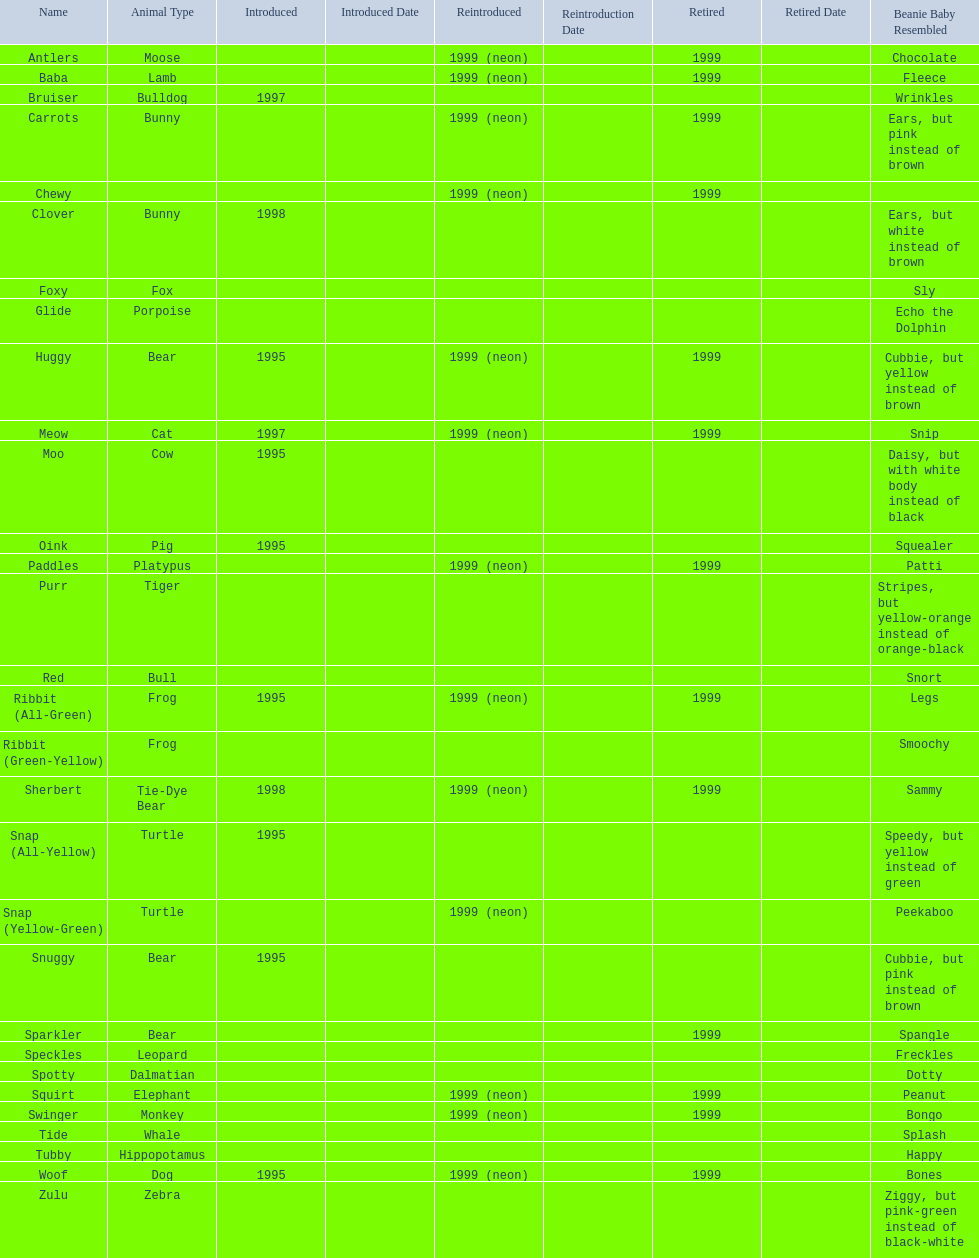What are all the different names of the pillow pals? Antlers, Baba, Bruiser, Carrots, Chewy, Clover, Foxy, Glide, Huggy, Meow, Moo, Oink, Paddles, Purr, Red, Ribbit (All-Green), Ribbit (Green-Yellow), Sherbert, Snap (All-Yellow), Snap (Yellow-Green), Snuggy, Sparkler, Speckles, Spotty, Squirt, Swinger, Tide, Tubby, Woof, Zulu. Which of these are a dalmatian? Spotty. 